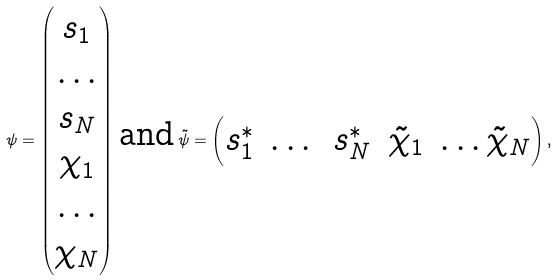<formula> <loc_0><loc_0><loc_500><loc_500>\psi = \begin{pmatrix} s _ { 1 } \\ \dots \\ s _ { N } \\ \chi _ { 1 } \\ \dots \\ \chi _ { N } \end{pmatrix} \, \text {and} \, \tilde { \psi } = \begin{pmatrix} s _ { 1 } ^ { * } & \dots & s _ { N } ^ { * } & \tilde { \chi } _ { 1 } & \dots \tilde { \chi } _ { N } \end{pmatrix} ,</formula> 